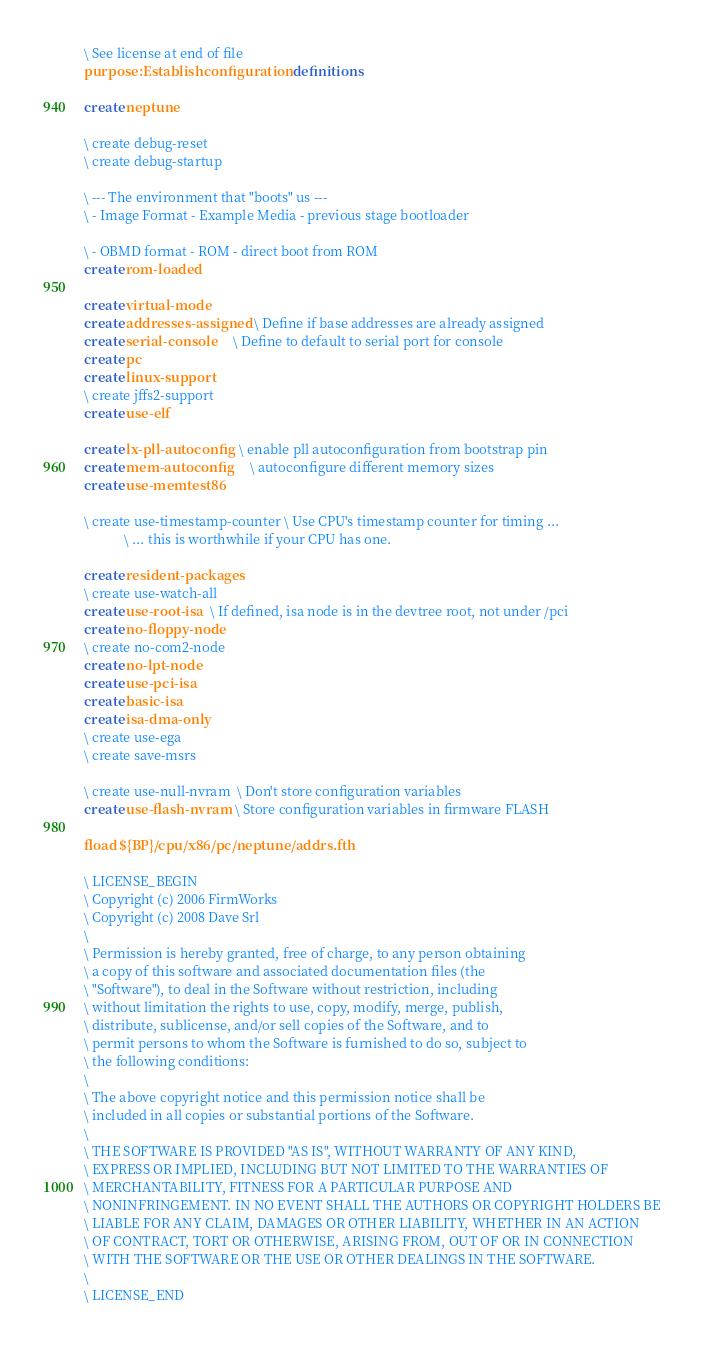Convert code to text. <code><loc_0><loc_0><loc_500><loc_500><_Forth_>\ See license at end of file
purpose: Establish configuration definitions

create neptune

\ create debug-reset
\ create debug-startup

\ --- The environment that "boots" us ---
\ - Image Format - Example Media - previous stage bootloader

\ - OBMD format - ROM - direct boot from ROM
create rom-loaded

create virtual-mode
create addresses-assigned  \ Define if base addresses are already assigned
create serial-console      \ Define to default to serial port for console
create pc
create linux-support
\ create jffs2-support
create use-elf

create lx-pll-autoconfig   \ enable pll autoconfiguration from bootstrap pin
create mem-autoconfig      \ autoconfigure different memory sizes
create use-memtest86

\ create use-timestamp-counter \ Use CPU's timestamp counter for timing ...
			\ ... this is worthwhile if your CPU has one.

create resident-packages
\ create use-watch-all
create use-root-isa   \ If defined, isa node is in the devtree root, not under /pci
create no-floppy-node
\ create no-com2-node
create no-lpt-node
create use-pci-isa
create basic-isa
create isa-dma-only
\ create use-ega
\ create save-msrs

\ create use-null-nvram  \ Don't store configuration variables
create use-flash-nvram  \ Store configuration variables in firmware FLASH

fload ${BP}/cpu/x86/pc/neptune/addrs.fth

\ LICENSE_BEGIN
\ Copyright (c) 2006 FirmWorks
\ Copyright (c) 2008 Dave Srl
\
\ Permission is hereby granted, free of charge, to any person obtaining
\ a copy of this software and associated documentation files (the
\ "Software"), to deal in the Software without restriction, including
\ without limitation the rights to use, copy, modify, merge, publish,
\ distribute, sublicense, and/or sell copies of the Software, and to
\ permit persons to whom the Software is furnished to do so, subject to
\ the following conditions:
\ 
\ The above copyright notice and this permission notice shall be
\ included in all copies or substantial portions of the Software.
\ 
\ THE SOFTWARE IS PROVIDED "AS IS", WITHOUT WARRANTY OF ANY KIND,
\ EXPRESS OR IMPLIED, INCLUDING BUT NOT LIMITED TO THE WARRANTIES OF
\ MERCHANTABILITY, FITNESS FOR A PARTICULAR PURPOSE AND
\ NONINFRINGEMENT. IN NO EVENT SHALL THE AUTHORS OR COPYRIGHT HOLDERS BE
\ LIABLE FOR ANY CLAIM, DAMAGES OR OTHER LIABILITY, WHETHER IN AN ACTION
\ OF CONTRACT, TORT OR OTHERWISE, ARISING FROM, OUT OF OR IN CONNECTION
\ WITH THE SOFTWARE OR THE USE OR OTHER DEALINGS IN THE SOFTWARE.
\
\ LICENSE_END
</code> 